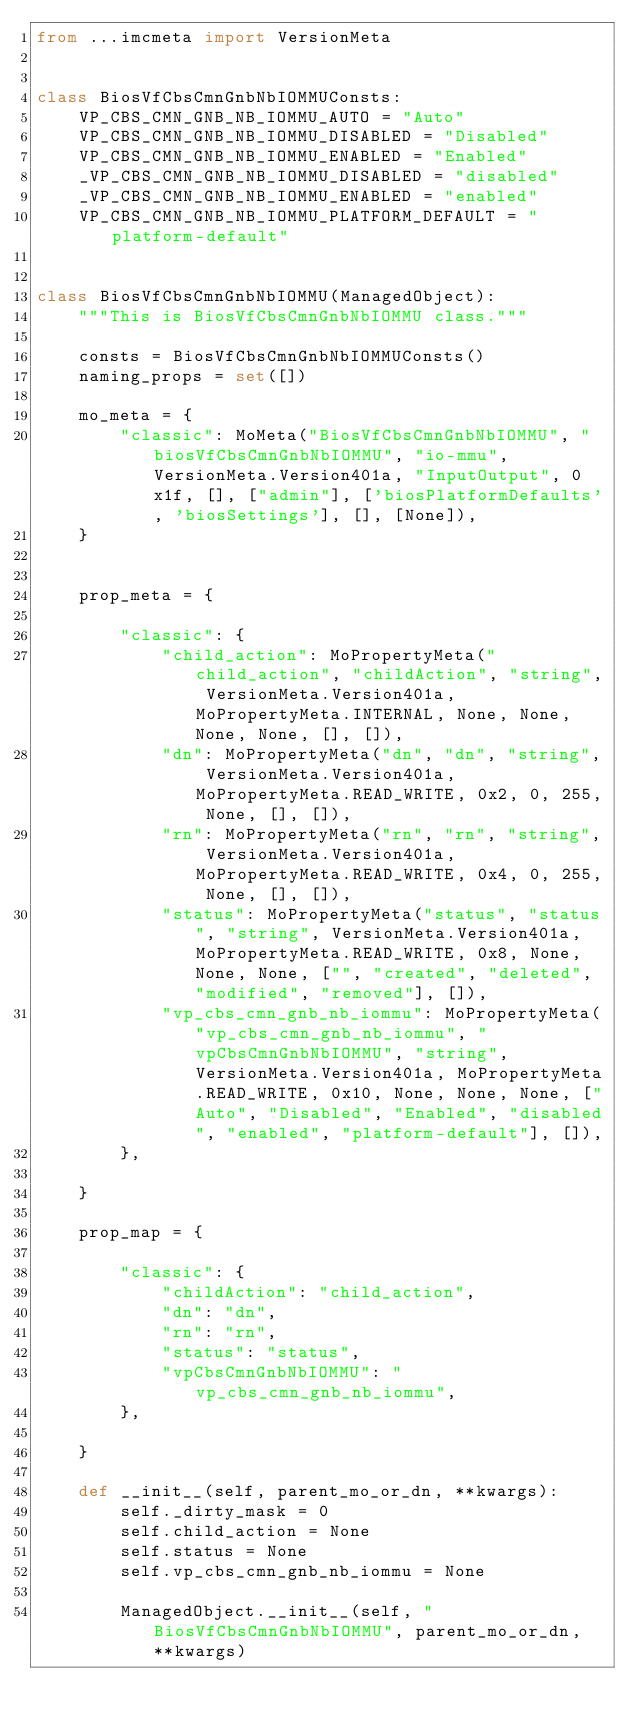Convert code to text. <code><loc_0><loc_0><loc_500><loc_500><_Python_>from ...imcmeta import VersionMeta


class BiosVfCbsCmnGnbNbIOMMUConsts:
    VP_CBS_CMN_GNB_NB_IOMMU_AUTO = "Auto"
    VP_CBS_CMN_GNB_NB_IOMMU_DISABLED = "Disabled"
    VP_CBS_CMN_GNB_NB_IOMMU_ENABLED = "Enabled"
    _VP_CBS_CMN_GNB_NB_IOMMU_DISABLED = "disabled"
    _VP_CBS_CMN_GNB_NB_IOMMU_ENABLED = "enabled"
    VP_CBS_CMN_GNB_NB_IOMMU_PLATFORM_DEFAULT = "platform-default"


class BiosVfCbsCmnGnbNbIOMMU(ManagedObject):
    """This is BiosVfCbsCmnGnbNbIOMMU class."""

    consts = BiosVfCbsCmnGnbNbIOMMUConsts()
    naming_props = set([])

    mo_meta = {
        "classic": MoMeta("BiosVfCbsCmnGnbNbIOMMU", "biosVfCbsCmnGnbNbIOMMU", "io-mmu", VersionMeta.Version401a, "InputOutput", 0x1f, [], ["admin"], ['biosPlatformDefaults', 'biosSettings'], [], [None]),
    }


    prop_meta = {

        "classic": {
            "child_action": MoPropertyMeta("child_action", "childAction", "string", VersionMeta.Version401a, MoPropertyMeta.INTERNAL, None, None, None, None, [], []),
            "dn": MoPropertyMeta("dn", "dn", "string", VersionMeta.Version401a, MoPropertyMeta.READ_WRITE, 0x2, 0, 255, None, [], []),
            "rn": MoPropertyMeta("rn", "rn", "string", VersionMeta.Version401a, MoPropertyMeta.READ_WRITE, 0x4, 0, 255, None, [], []),
            "status": MoPropertyMeta("status", "status", "string", VersionMeta.Version401a, MoPropertyMeta.READ_WRITE, 0x8, None, None, None, ["", "created", "deleted", "modified", "removed"], []),
            "vp_cbs_cmn_gnb_nb_iommu": MoPropertyMeta("vp_cbs_cmn_gnb_nb_iommu", "vpCbsCmnGnbNbIOMMU", "string", VersionMeta.Version401a, MoPropertyMeta.READ_WRITE, 0x10, None, None, None, ["Auto", "Disabled", "Enabled", "disabled", "enabled", "platform-default"], []),
        },

    }

    prop_map = {

        "classic": {
            "childAction": "child_action", 
            "dn": "dn", 
            "rn": "rn", 
            "status": "status", 
            "vpCbsCmnGnbNbIOMMU": "vp_cbs_cmn_gnb_nb_iommu", 
        },

    }

    def __init__(self, parent_mo_or_dn, **kwargs):
        self._dirty_mask = 0
        self.child_action = None
        self.status = None
        self.vp_cbs_cmn_gnb_nb_iommu = None

        ManagedObject.__init__(self, "BiosVfCbsCmnGnbNbIOMMU", parent_mo_or_dn, **kwargs)

</code> 